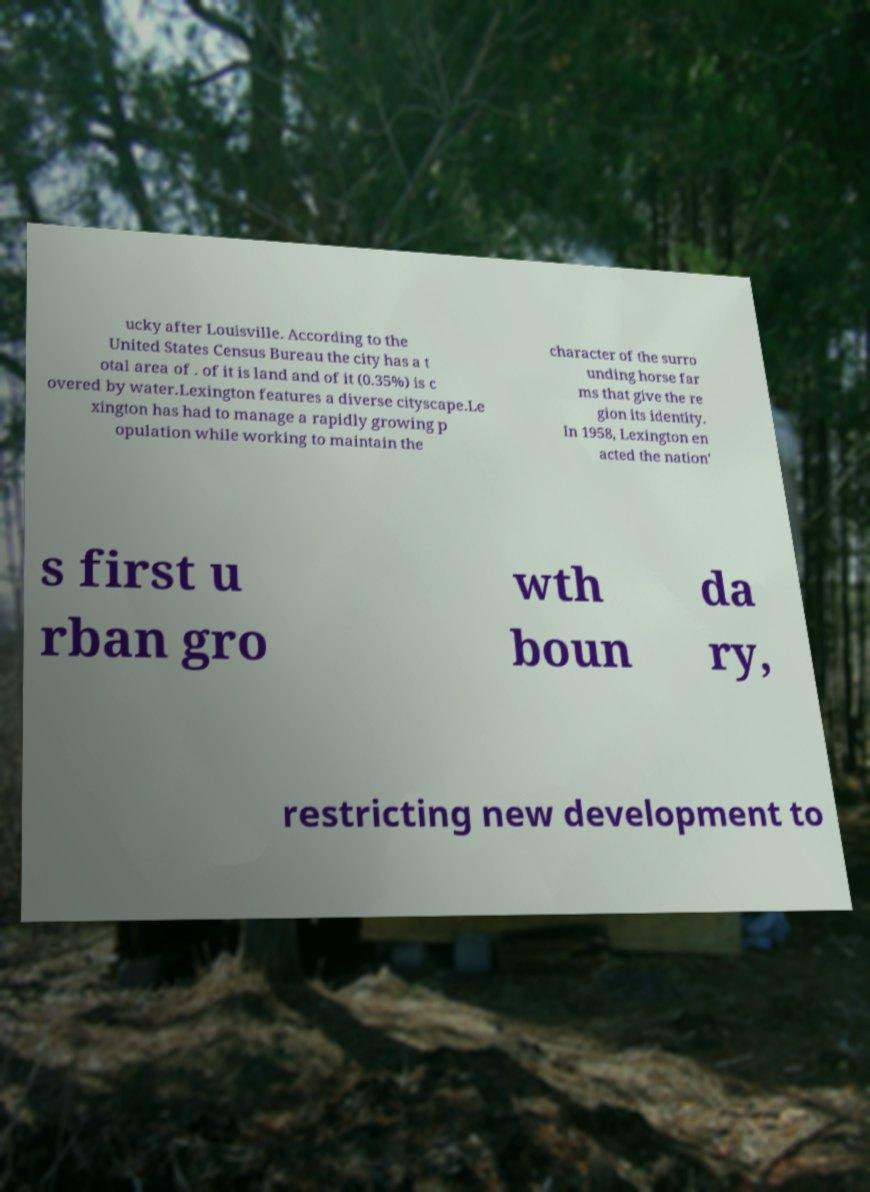I need the written content from this picture converted into text. Can you do that? ucky after Louisville. According to the United States Census Bureau the city has a t otal area of . of it is land and of it (0.35%) is c overed by water.Lexington features a diverse cityscape.Le xington has had to manage a rapidly growing p opulation while working to maintain the character of the surro unding horse far ms that give the re gion its identity. In 1958, Lexington en acted the nation' s first u rban gro wth boun da ry, restricting new development to 